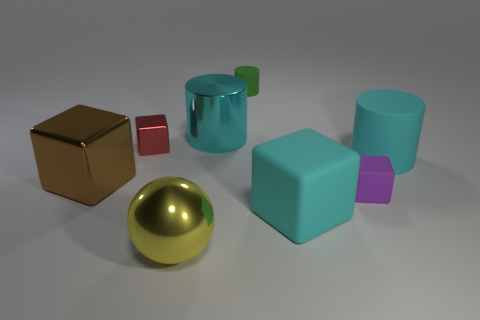Add 1 yellow spheres. How many objects exist? 9 Subtract all cylinders. How many objects are left? 5 Add 6 matte cylinders. How many matte cylinders are left? 8 Add 5 big yellow balls. How many big yellow balls exist? 6 Subtract 0 green blocks. How many objects are left? 8 Subtract all large purple objects. Subtract all purple things. How many objects are left? 7 